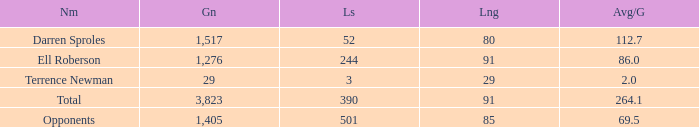What's the sum of all average yards gained when the gained yards is under 1,276 and lost more than 3 yards? None. 